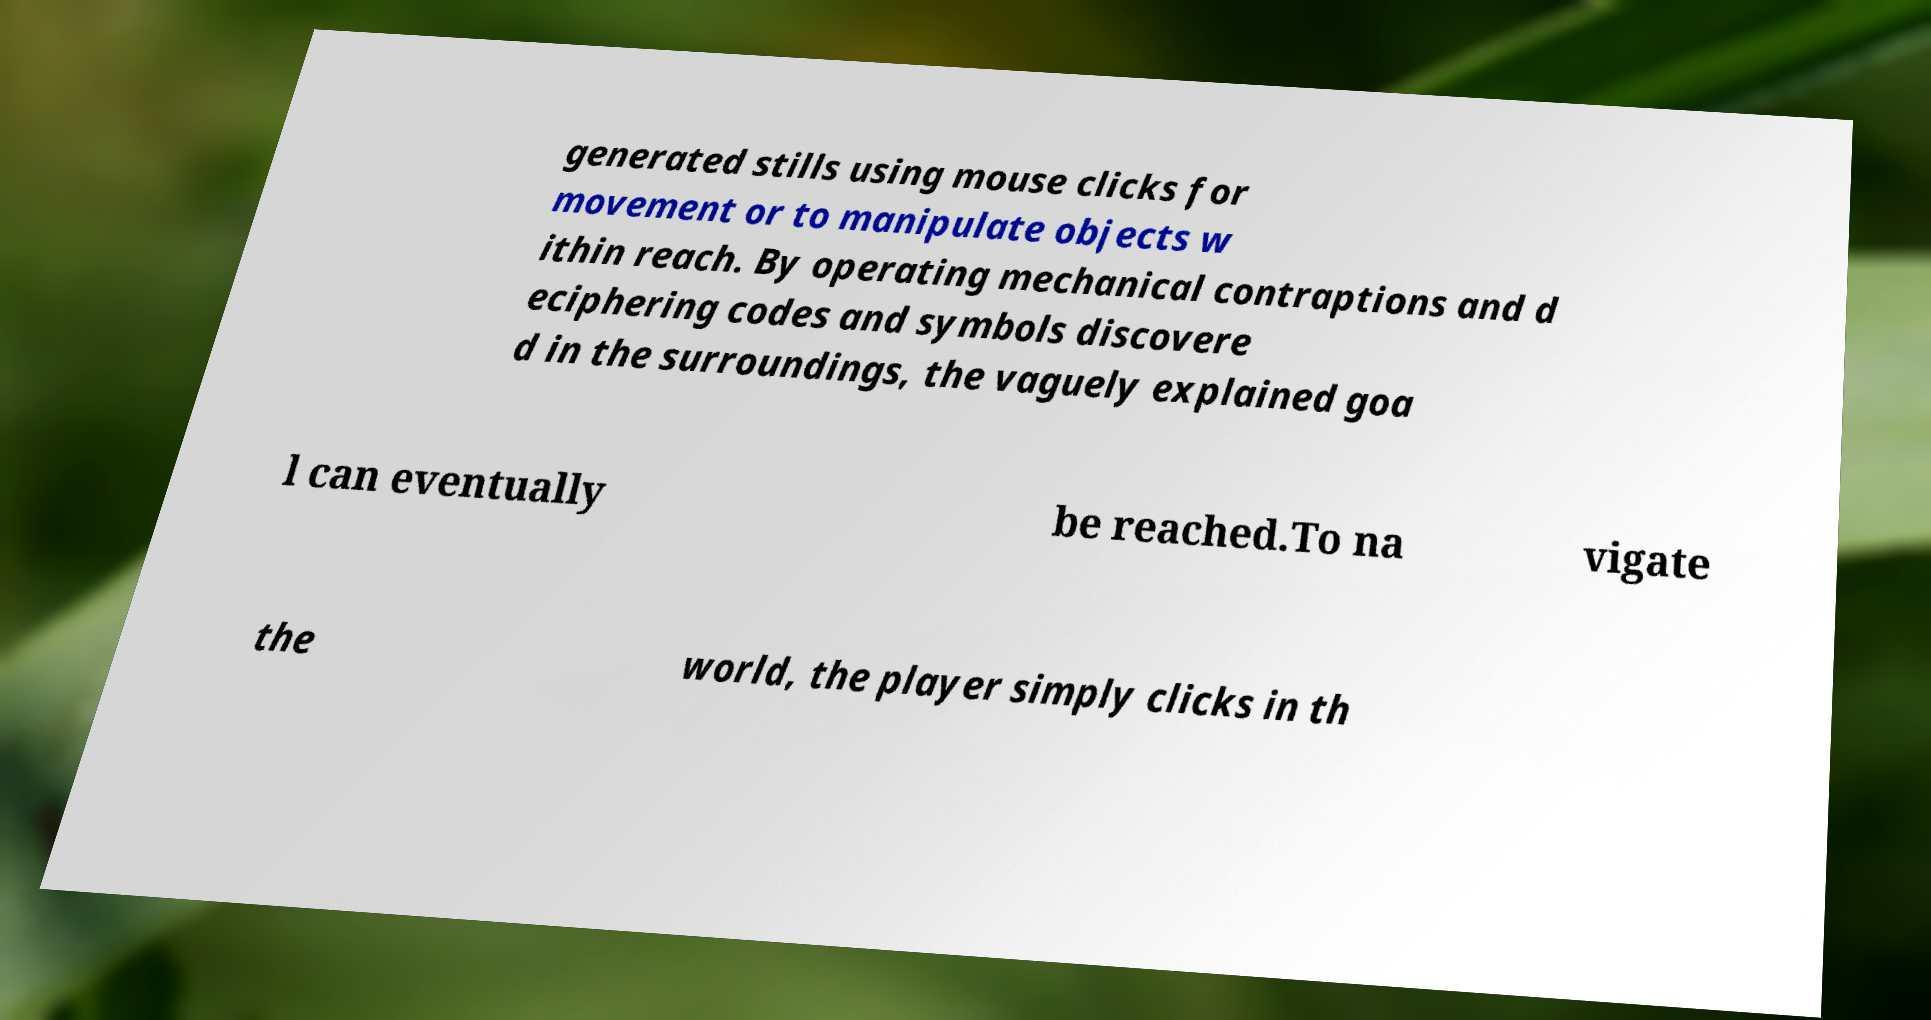Can you accurately transcribe the text from the provided image for me? generated stills using mouse clicks for movement or to manipulate objects w ithin reach. By operating mechanical contraptions and d eciphering codes and symbols discovere d in the surroundings, the vaguely explained goa l can eventually be reached.To na vigate the world, the player simply clicks in th 